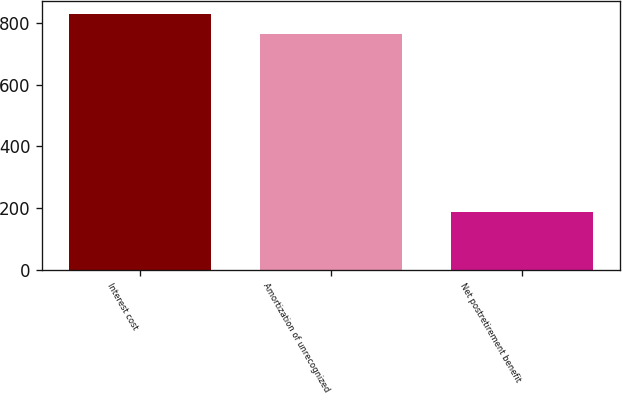<chart> <loc_0><loc_0><loc_500><loc_500><bar_chart><fcel>Interest cost<fcel>Amortization of unrecognized<fcel>Net postretirement benefit<nl><fcel>829.7<fcel>764<fcel>187.7<nl></chart> 